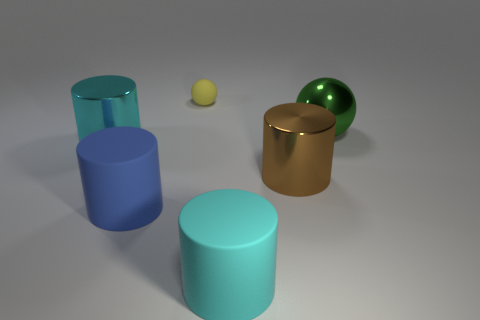How many other things are there of the same material as the big brown cylinder? There are two items that appear to be made of the same glossy material as the large brown cylinder: one smaller green sphere and one smaller golden cylinder. 